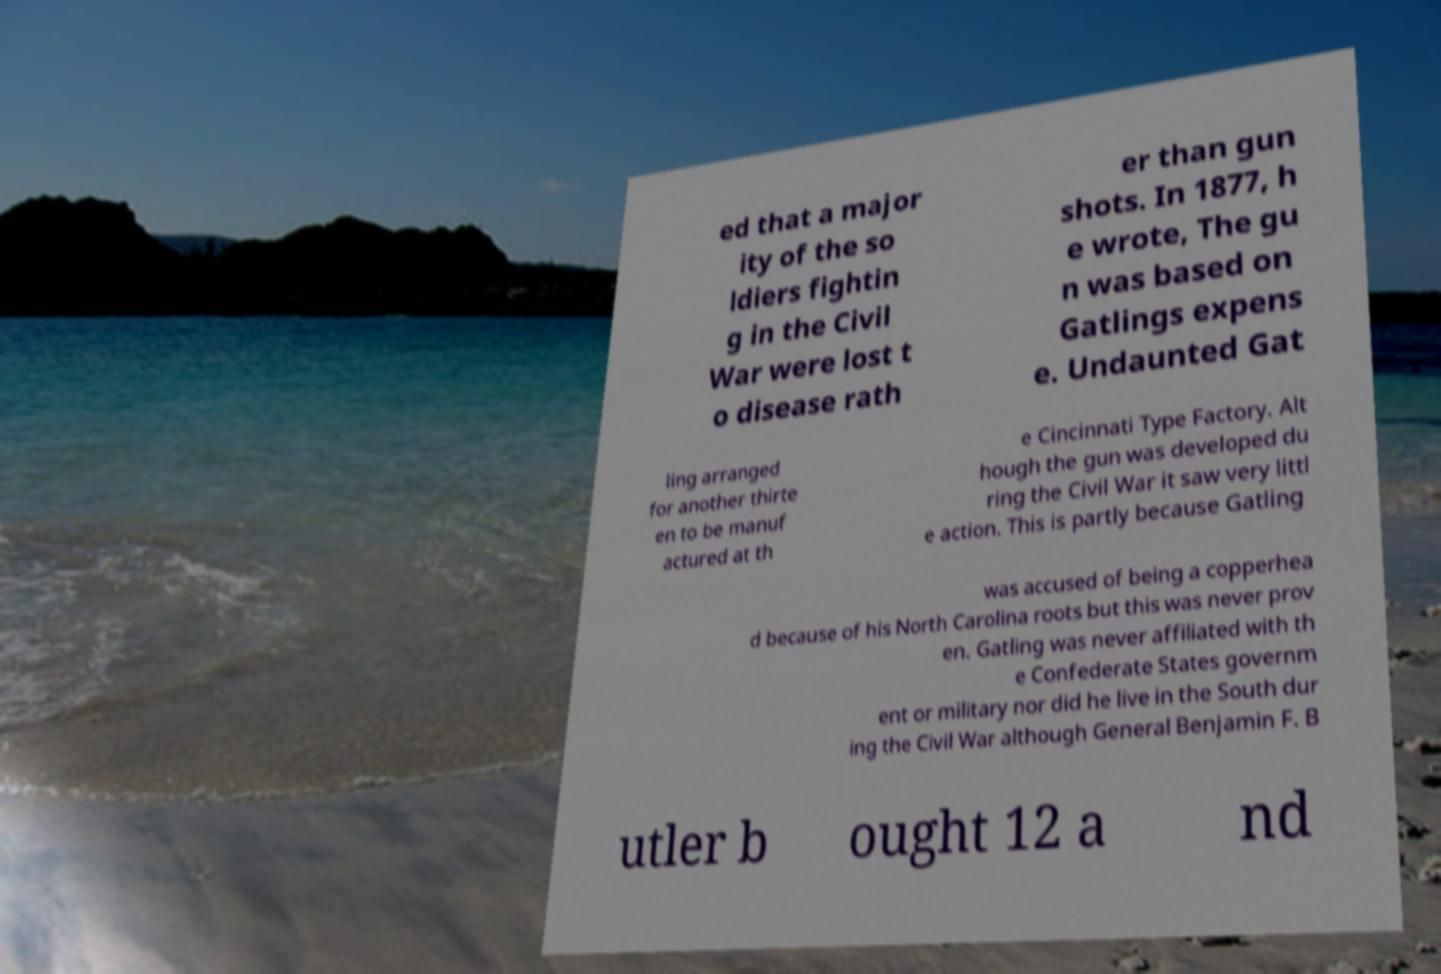For documentation purposes, I need the text within this image transcribed. Could you provide that? ed that a major ity of the so ldiers fightin g in the Civil War were lost t o disease rath er than gun shots. In 1877, h e wrote, The gu n was based on Gatlings expens e. Undaunted Gat ling arranged for another thirte en to be manuf actured at th e Cincinnati Type Factory. Alt hough the gun was developed du ring the Civil War it saw very littl e action. This is partly because Gatling was accused of being a copperhea d because of his North Carolina roots but this was never prov en. Gatling was never affiliated with th e Confederate States governm ent or military nor did he live in the South dur ing the Civil War although General Benjamin F. B utler b ought 12 a nd 